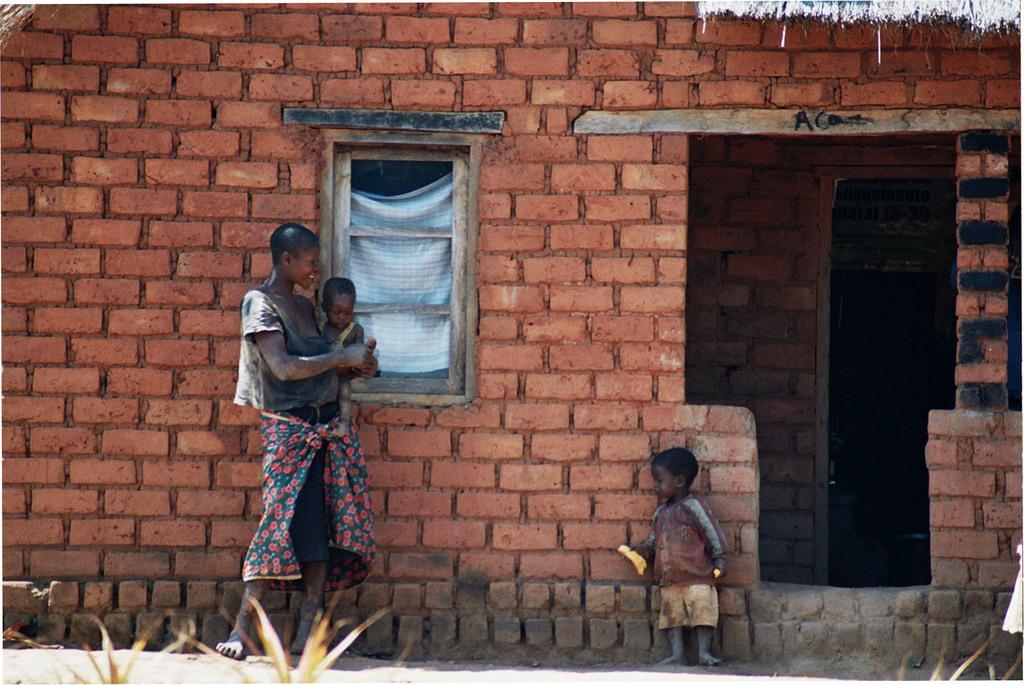Can you describe this image briefly? In this picture we can see a woman and two kids, at the bottom there are plants, we can see a house in the background, there is a window in the middle. 